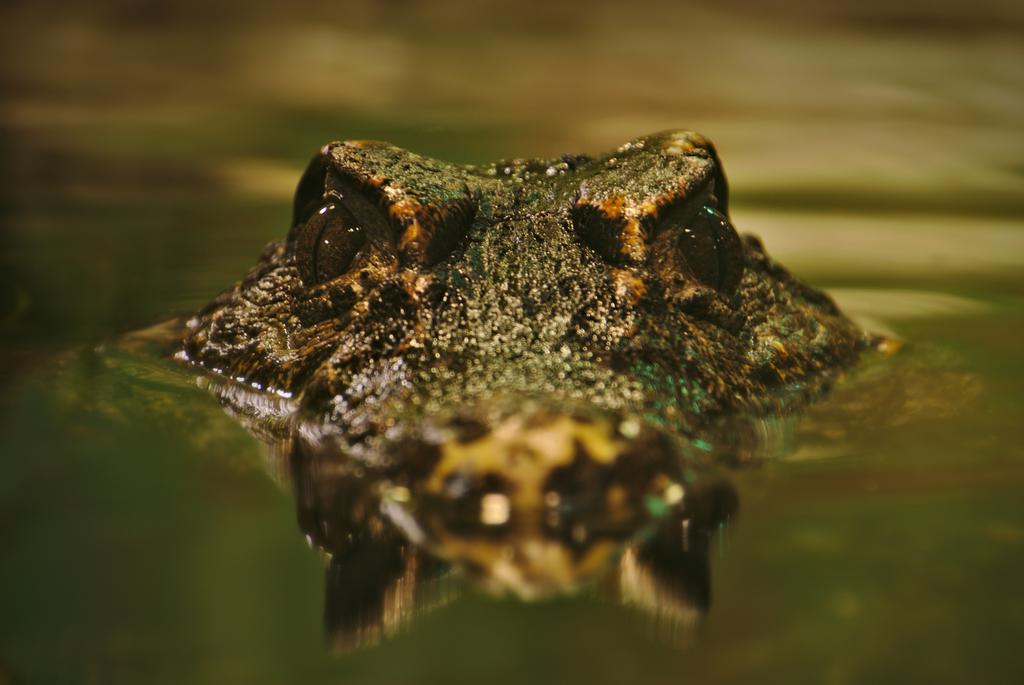What type of animal is in the water in the image? There is a crocodile in the water in the image. What type of root can be seen growing near the crocodile in the image? There is no root visible in the image; it only features a crocodile in the water. 